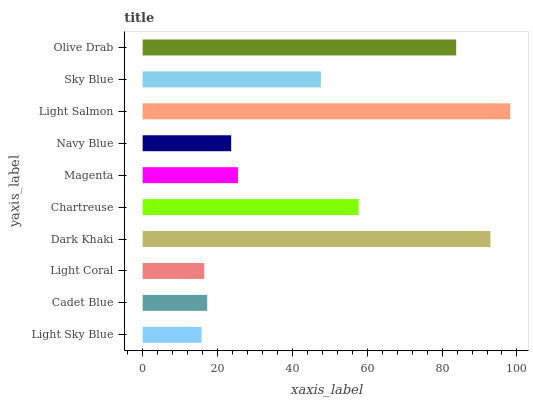Is Light Sky Blue the minimum?
Answer yes or no. Yes. Is Light Salmon the maximum?
Answer yes or no. Yes. Is Cadet Blue the minimum?
Answer yes or no. No. Is Cadet Blue the maximum?
Answer yes or no. No. Is Cadet Blue greater than Light Sky Blue?
Answer yes or no. Yes. Is Light Sky Blue less than Cadet Blue?
Answer yes or no. Yes. Is Light Sky Blue greater than Cadet Blue?
Answer yes or no. No. Is Cadet Blue less than Light Sky Blue?
Answer yes or no. No. Is Sky Blue the high median?
Answer yes or no. Yes. Is Magenta the low median?
Answer yes or no. Yes. Is Dark Khaki the high median?
Answer yes or no. No. Is Light Coral the low median?
Answer yes or no. No. 